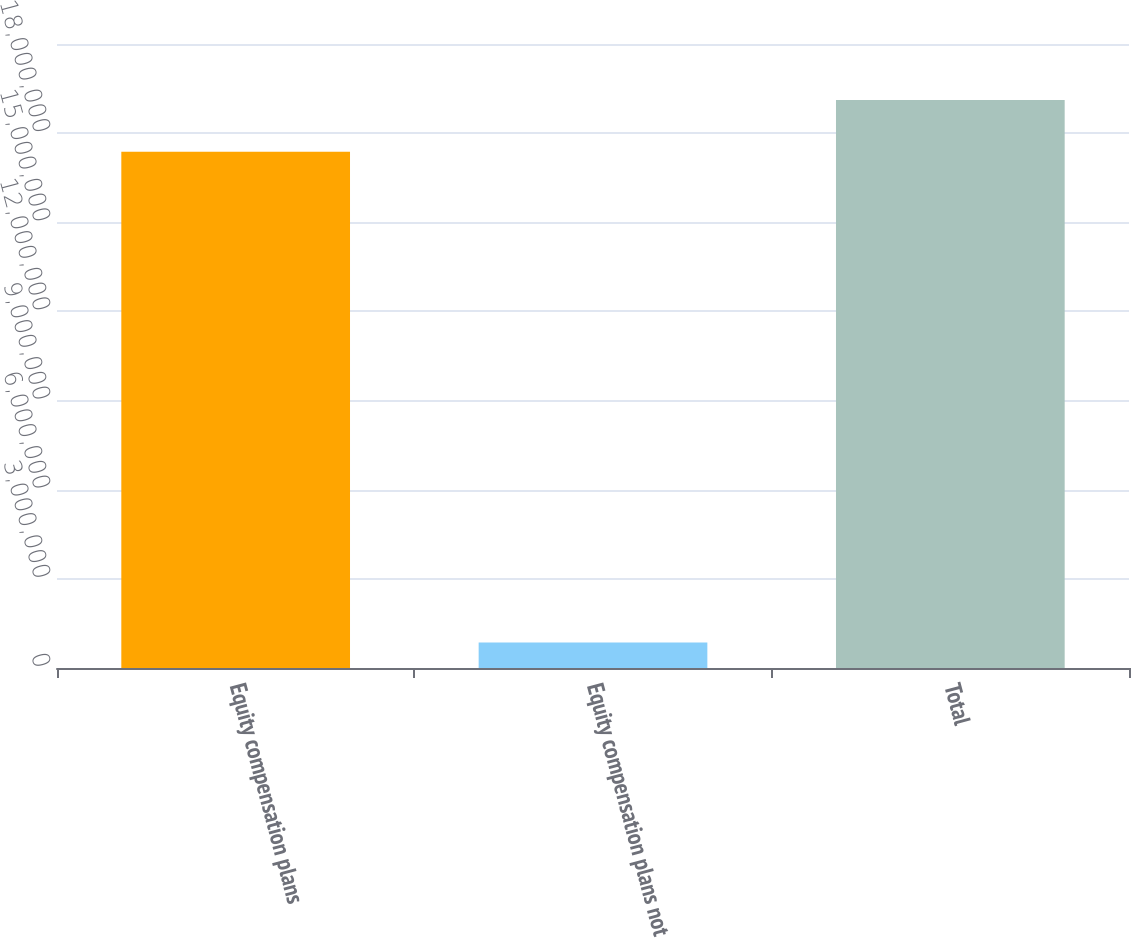Convert chart to OTSL. <chart><loc_0><loc_0><loc_500><loc_500><bar_chart><fcel>Equity compensation plans<fcel>Equity compensation plans not<fcel>Total<nl><fcel>1.73758e+07<fcel>854600<fcel>1.91134e+07<nl></chart> 